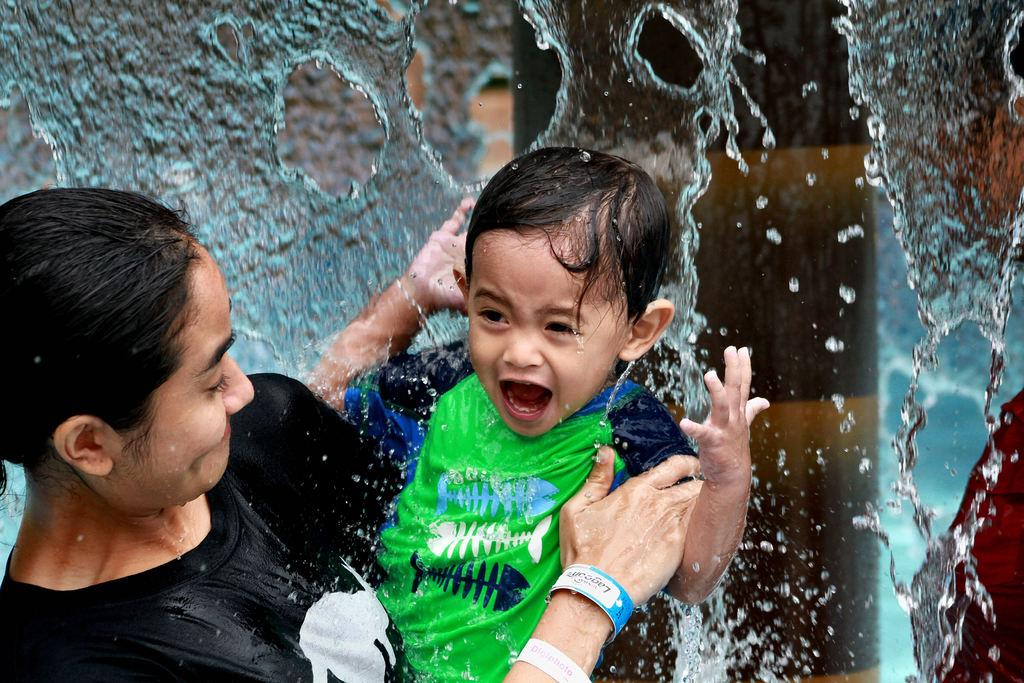Who is the main subject in the image? There is a woman in the image. What is the woman wearing? The woman is wearing a black T-shirt. What is the woman doing in the image? The woman is holding a kid. What can be seen at the top of the image? There is water visible at the top of the image. What architectural feature is visible in the background of the image? There appears to be a pillar in the background of the image. What type of nerve can be seen affecting the woman's movements in the image? There is no mention of any nerve affecting the woman's movements in the image; she is simply holding a kid. What direction is the zephyr blowing in the image? There is no mention of a zephyr or any wind in the image. 